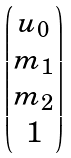Convert formula to latex. <formula><loc_0><loc_0><loc_500><loc_500>\begin{pmatrix} u _ { 0 } \\ m _ { 1 } \\ m _ { 2 } \\ 1 \end{pmatrix}</formula> 